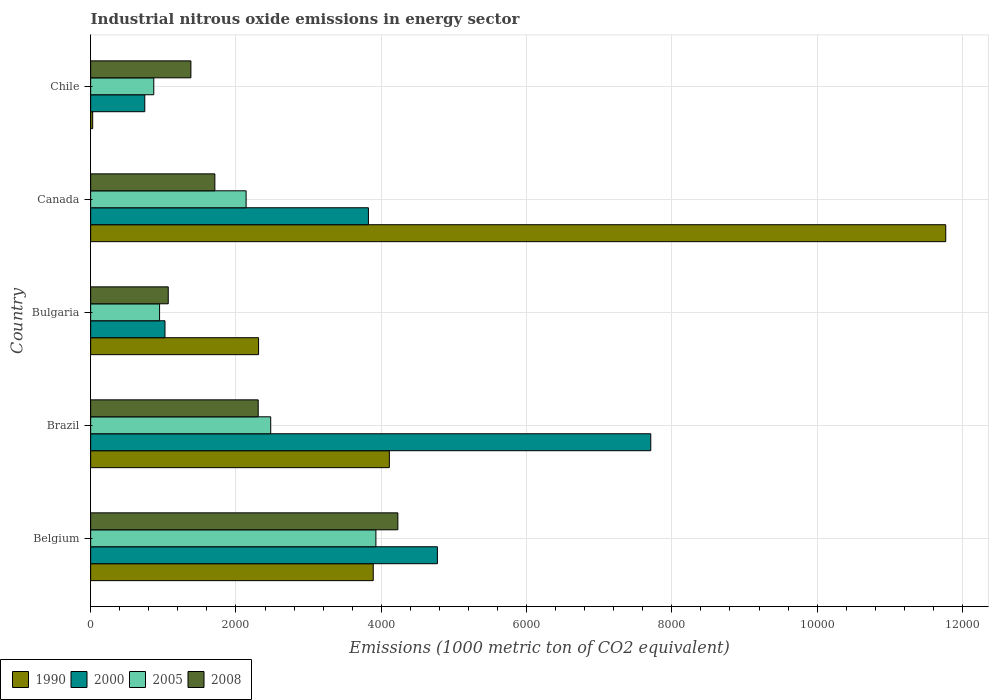How many bars are there on the 1st tick from the bottom?
Provide a succinct answer. 4. What is the amount of industrial nitrous oxide emitted in 2000 in Belgium?
Provide a short and direct response. 4772.6. Across all countries, what is the maximum amount of industrial nitrous oxide emitted in 2005?
Ensure brevity in your answer.  3926.3. Across all countries, what is the minimum amount of industrial nitrous oxide emitted in 2005?
Keep it short and to the point. 868.8. In which country was the amount of industrial nitrous oxide emitted in 2008 maximum?
Your answer should be very brief. Belgium. What is the total amount of industrial nitrous oxide emitted in 2000 in the graph?
Provide a succinct answer. 1.81e+04. What is the difference between the amount of industrial nitrous oxide emitted in 1990 in Belgium and that in Chile?
Make the answer very short. 3861.7. What is the difference between the amount of industrial nitrous oxide emitted in 2000 in Chile and the amount of industrial nitrous oxide emitted in 1990 in Bulgaria?
Give a very brief answer. -1566.3. What is the average amount of industrial nitrous oxide emitted in 2008 per country?
Offer a very short reply. 2138.42. What is the difference between the amount of industrial nitrous oxide emitted in 2008 and amount of industrial nitrous oxide emitted in 2000 in Canada?
Your answer should be very brief. -2113.7. What is the ratio of the amount of industrial nitrous oxide emitted in 1990 in Bulgaria to that in Canada?
Provide a short and direct response. 0.2. Is the difference between the amount of industrial nitrous oxide emitted in 2008 in Brazil and Canada greater than the difference between the amount of industrial nitrous oxide emitted in 2000 in Brazil and Canada?
Make the answer very short. No. What is the difference between the highest and the second highest amount of industrial nitrous oxide emitted in 1990?
Your response must be concise. 7658.6. What is the difference between the highest and the lowest amount of industrial nitrous oxide emitted in 2005?
Offer a terse response. 3057.5. Is it the case that in every country, the sum of the amount of industrial nitrous oxide emitted in 2005 and amount of industrial nitrous oxide emitted in 1990 is greater than the sum of amount of industrial nitrous oxide emitted in 2000 and amount of industrial nitrous oxide emitted in 2008?
Your answer should be compact. No. What does the 4th bar from the bottom in Bulgaria represents?
Keep it short and to the point. 2008. Is it the case that in every country, the sum of the amount of industrial nitrous oxide emitted in 1990 and amount of industrial nitrous oxide emitted in 2005 is greater than the amount of industrial nitrous oxide emitted in 2008?
Make the answer very short. No. What is the difference between two consecutive major ticks on the X-axis?
Make the answer very short. 2000. Are the values on the major ticks of X-axis written in scientific E-notation?
Keep it short and to the point. No. Where does the legend appear in the graph?
Make the answer very short. Bottom left. How many legend labels are there?
Provide a short and direct response. 4. How are the legend labels stacked?
Ensure brevity in your answer.  Horizontal. What is the title of the graph?
Ensure brevity in your answer.  Industrial nitrous oxide emissions in energy sector. What is the label or title of the X-axis?
Give a very brief answer. Emissions (1000 metric ton of CO2 equivalent). What is the Emissions (1000 metric ton of CO2 equivalent) in 1990 in Belgium?
Your answer should be very brief. 3889.6. What is the Emissions (1000 metric ton of CO2 equivalent) in 2000 in Belgium?
Make the answer very short. 4772.6. What is the Emissions (1000 metric ton of CO2 equivalent) of 2005 in Belgium?
Offer a terse response. 3926.3. What is the Emissions (1000 metric ton of CO2 equivalent) of 2008 in Belgium?
Your answer should be compact. 4228.6. What is the Emissions (1000 metric ton of CO2 equivalent) in 1990 in Brazil?
Ensure brevity in your answer.  4111.4. What is the Emissions (1000 metric ton of CO2 equivalent) in 2000 in Brazil?
Your response must be concise. 7709.7. What is the Emissions (1000 metric ton of CO2 equivalent) in 2005 in Brazil?
Provide a short and direct response. 2478.5. What is the Emissions (1000 metric ton of CO2 equivalent) of 2008 in Brazil?
Give a very brief answer. 2306.2. What is the Emissions (1000 metric ton of CO2 equivalent) of 1990 in Bulgaria?
Give a very brief answer. 2311.2. What is the Emissions (1000 metric ton of CO2 equivalent) of 2000 in Bulgaria?
Keep it short and to the point. 1023. What is the Emissions (1000 metric ton of CO2 equivalent) in 2005 in Bulgaria?
Offer a terse response. 948.6. What is the Emissions (1000 metric ton of CO2 equivalent) of 2008 in Bulgaria?
Offer a very short reply. 1068. What is the Emissions (1000 metric ton of CO2 equivalent) of 1990 in Canada?
Offer a very short reply. 1.18e+04. What is the Emissions (1000 metric ton of CO2 equivalent) of 2000 in Canada?
Your answer should be very brief. 3823.3. What is the Emissions (1000 metric ton of CO2 equivalent) in 2005 in Canada?
Your response must be concise. 2139.7. What is the Emissions (1000 metric ton of CO2 equivalent) in 2008 in Canada?
Provide a short and direct response. 1709.6. What is the Emissions (1000 metric ton of CO2 equivalent) of 1990 in Chile?
Give a very brief answer. 27.9. What is the Emissions (1000 metric ton of CO2 equivalent) in 2000 in Chile?
Your answer should be compact. 744.9. What is the Emissions (1000 metric ton of CO2 equivalent) of 2005 in Chile?
Keep it short and to the point. 868.8. What is the Emissions (1000 metric ton of CO2 equivalent) in 2008 in Chile?
Provide a succinct answer. 1379.7. Across all countries, what is the maximum Emissions (1000 metric ton of CO2 equivalent) in 1990?
Provide a succinct answer. 1.18e+04. Across all countries, what is the maximum Emissions (1000 metric ton of CO2 equivalent) in 2000?
Ensure brevity in your answer.  7709.7. Across all countries, what is the maximum Emissions (1000 metric ton of CO2 equivalent) of 2005?
Ensure brevity in your answer.  3926.3. Across all countries, what is the maximum Emissions (1000 metric ton of CO2 equivalent) in 2008?
Offer a very short reply. 4228.6. Across all countries, what is the minimum Emissions (1000 metric ton of CO2 equivalent) in 1990?
Offer a very short reply. 27.9. Across all countries, what is the minimum Emissions (1000 metric ton of CO2 equivalent) in 2000?
Offer a very short reply. 744.9. Across all countries, what is the minimum Emissions (1000 metric ton of CO2 equivalent) of 2005?
Offer a terse response. 868.8. Across all countries, what is the minimum Emissions (1000 metric ton of CO2 equivalent) of 2008?
Your response must be concise. 1068. What is the total Emissions (1000 metric ton of CO2 equivalent) in 1990 in the graph?
Ensure brevity in your answer.  2.21e+04. What is the total Emissions (1000 metric ton of CO2 equivalent) of 2000 in the graph?
Make the answer very short. 1.81e+04. What is the total Emissions (1000 metric ton of CO2 equivalent) in 2005 in the graph?
Ensure brevity in your answer.  1.04e+04. What is the total Emissions (1000 metric ton of CO2 equivalent) of 2008 in the graph?
Offer a very short reply. 1.07e+04. What is the difference between the Emissions (1000 metric ton of CO2 equivalent) in 1990 in Belgium and that in Brazil?
Keep it short and to the point. -221.8. What is the difference between the Emissions (1000 metric ton of CO2 equivalent) in 2000 in Belgium and that in Brazil?
Give a very brief answer. -2937.1. What is the difference between the Emissions (1000 metric ton of CO2 equivalent) in 2005 in Belgium and that in Brazil?
Provide a short and direct response. 1447.8. What is the difference between the Emissions (1000 metric ton of CO2 equivalent) of 2008 in Belgium and that in Brazil?
Your answer should be compact. 1922.4. What is the difference between the Emissions (1000 metric ton of CO2 equivalent) in 1990 in Belgium and that in Bulgaria?
Your answer should be compact. 1578.4. What is the difference between the Emissions (1000 metric ton of CO2 equivalent) of 2000 in Belgium and that in Bulgaria?
Your answer should be very brief. 3749.6. What is the difference between the Emissions (1000 metric ton of CO2 equivalent) in 2005 in Belgium and that in Bulgaria?
Give a very brief answer. 2977.7. What is the difference between the Emissions (1000 metric ton of CO2 equivalent) in 2008 in Belgium and that in Bulgaria?
Your answer should be very brief. 3160.6. What is the difference between the Emissions (1000 metric ton of CO2 equivalent) of 1990 in Belgium and that in Canada?
Provide a succinct answer. -7880.4. What is the difference between the Emissions (1000 metric ton of CO2 equivalent) in 2000 in Belgium and that in Canada?
Your response must be concise. 949.3. What is the difference between the Emissions (1000 metric ton of CO2 equivalent) in 2005 in Belgium and that in Canada?
Ensure brevity in your answer.  1786.6. What is the difference between the Emissions (1000 metric ton of CO2 equivalent) in 2008 in Belgium and that in Canada?
Provide a short and direct response. 2519. What is the difference between the Emissions (1000 metric ton of CO2 equivalent) in 1990 in Belgium and that in Chile?
Give a very brief answer. 3861.7. What is the difference between the Emissions (1000 metric ton of CO2 equivalent) of 2000 in Belgium and that in Chile?
Your response must be concise. 4027.7. What is the difference between the Emissions (1000 metric ton of CO2 equivalent) in 2005 in Belgium and that in Chile?
Make the answer very short. 3057.5. What is the difference between the Emissions (1000 metric ton of CO2 equivalent) in 2008 in Belgium and that in Chile?
Ensure brevity in your answer.  2848.9. What is the difference between the Emissions (1000 metric ton of CO2 equivalent) of 1990 in Brazil and that in Bulgaria?
Provide a succinct answer. 1800.2. What is the difference between the Emissions (1000 metric ton of CO2 equivalent) of 2000 in Brazil and that in Bulgaria?
Offer a terse response. 6686.7. What is the difference between the Emissions (1000 metric ton of CO2 equivalent) in 2005 in Brazil and that in Bulgaria?
Provide a succinct answer. 1529.9. What is the difference between the Emissions (1000 metric ton of CO2 equivalent) in 2008 in Brazil and that in Bulgaria?
Provide a succinct answer. 1238.2. What is the difference between the Emissions (1000 metric ton of CO2 equivalent) in 1990 in Brazil and that in Canada?
Your response must be concise. -7658.6. What is the difference between the Emissions (1000 metric ton of CO2 equivalent) in 2000 in Brazil and that in Canada?
Provide a short and direct response. 3886.4. What is the difference between the Emissions (1000 metric ton of CO2 equivalent) in 2005 in Brazil and that in Canada?
Keep it short and to the point. 338.8. What is the difference between the Emissions (1000 metric ton of CO2 equivalent) of 2008 in Brazil and that in Canada?
Your answer should be compact. 596.6. What is the difference between the Emissions (1000 metric ton of CO2 equivalent) in 1990 in Brazil and that in Chile?
Your answer should be compact. 4083.5. What is the difference between the Emissions (1000 metric ton of CO2 equivalent) of 2000 in Brazil and that in Chile?
Provide a succinct answer. 6964.8. What is the difference between the Emissions (1000 metric ton of CO2 equivalent) in 2005 in Brazil and that in Chile?
Offer a terse response. 1609.7. What is the difference between the Emissions (1000 metric ton of CO2 equivalent) in 2008 in Brazil and that in Chile?
Provide a succinct answer. 926.5. What is the difference between the Emissions (1000 metric ton of CO2 equivalent) in 1990 in Bulgaria and that in Canada?
Make the answer very short. -9458.8. What is the difference between the Emissions (1000 metric ton of CO2 equivalent) of 2000 in Bulgaria and that in Canada?
Provide a succinct answer. -2800.3. What is the difference between the Emissions (1000 metric ton of CO2 equivalent) in 2005 in Bulgaria and that in Canada?
Make the answer very short. -1191.1. What is the difference between the Emissions (1000 metric ton of CO2 equivalent) in 2008 in Bulgaria and that in Canada?
Keep it short and to the point. -641.6. What is the difference between the Emissions (1000 metric ton of CO2 equivalent) of 1990 in Bulgaria and that in Chile?
Your response must be concise. 2283.3. What is the difference between the Emissions (1000 metric ton of CO2 equivalent) in 2000 in Bulgaria and that in Chile?
Your response must be concise. 278.1. What is the difference between the Emissions (1000 metric ton of CO2 equivalent) of 2005 in Bulgaria and that in Chile?
Your answer should be compact. 79.8. What is the difference between the Emissions (1000 metric ton of CO2 equivalent) in 2008 in Bulgaria and that in Chile?
Give a very brief answer. -311.7. What is the difference between the Emissions (1000 metric ton of CO2 equivalent) in 1990 in Canada and that in Chile?
Offer a terse response. 1.17e+04. What is the difference between the Emissions (1000 metric ton of CO2 equivalent) in 2000 in Canada and that in Chile?
Give a very brief answer. 3078.4. What is the difference between the Emissions (1000 metric ton of CO2 equivalent) of 2005 in Canada and that in Chile?
Provide a short and direct response. 1270.9. What is the difference between the Emissions (1000 metric ton of CO2 equivalent) in 2008 in Canada and that in Chile?
Offer a terse response. 329.9. What is the difference between the Emissions (1000 metric ton of CO2 equivalent) in 1990 in Belgium and the Emissions (1000 metric ton of CO2 equivalent) in 2000 in Brazil?
Your answer should be very brief. -3820.1. What is the difference between the Emissions (1000 metric ton of CO2 equivalent) in 1990 in Belgium and the Emissions (1000 metric ton of CO2 equivalent) in 2005 in Brazil?
Your answer should be very brief. 1411.1. What is the difference between the Emissions (1000 metric ton of CO2 equivalent) of 1990 in Belgium and the Emissions (1000 metric ton of CO2 equivalent) of 2008 in Brazil?
Your answer should be very brief. 1583.4. What is the difference between the Emissions (1000 metric ton of CO2 equivalent) of 2000 in Belgium and the Emissions (1000 metric ton of CO2 equivalent) of 2005 in Brazil?
Give a very brief answer. 2294.1. What is the difference between the Emissions (1000 metric ton of CO2 equivalent) of 2000 in Belgium and the Emissions (1000 metric ton of CO2 equivalent) of 2008 in Brazil?
Offer a terse response. 2466.4. What is the difference between the Emissions (1000 metric ton of CO2 equivalent) of 2005 in Belgium and the Emissions (1000 metric ton of CO2 equivalent) of 2008 in Brazil?
Keep it short and to the point. 1620.1. What is the difference between the Emissions (1000 metric ton of CO2 equivalent) in 1990 in Belgium and the Emissions (1000 metric ton of CO2 equivalent) in 2000 in Bulgaria?
Your answer should be compact. 2866.6. What is the difference between the Emissions (1000 metric ton of CO2 equivalent) of 1990 in Belgium and the Emissions (1000 metric ton of CO2 equivalent) of 2005 in Bulgaria?
Ensure brevity in your answer.  2941. What is the difference between the Emissions (1000 metric ton of CO2 equivalent) of 1990 in Belgium and the Emissions (1000 metric ton of CO2 equivalent) of 2008 in Bulgaria?
Ensure brevity in your answer.  2821.6. What is the difference between the Emissions (1000 metric ton of CO2 equivalent) in 2000 in Belgium and the Emissions (1000 metric ton of CO2 equivalent) in 2005 in Bulgaria?
Your response must be concise. 3824. What is the difference between the Emissions (1000 metric ton of CO2 equivalent) of 2000 in Belgium and the Emissions (1000 metric ton of CO2 equivalent) of 2008 in Bulgaria?
Keep it short and to the point. 3704.6. What is the difference between the Emissions (1000 metric ton of CO2 equivalent) of 2005 in Belgium and the Emissions (1000 metric ton of CO2 equivalent) of 2008 in Bulgaria?
Your response must be concise. 2858.3. What is the difference between the Emissions (1000 metric ton of CO2 equivalent) in 1990 in Belgium and the Emissions (1000 metric ton of CO2 equivalent) in 2000 in Canada?
Offer a very short reply. 66.3. What is the difference between the Emissions (1000 metric ton of CO2 equivalent) in 1990 in Belgium and the Emissions (1000 metric ton of CO2 equivalent) in 2005 in Canada?
Provide a succinct answer. 1749.9. What is the difference between the Emissions (1000 metric ton of CO2 equivalent) of 1990 in Belgium and the Emissions (1000 metric ton of CO2 equivalent) of 2008 in Canada?
Offer a terse response. 2180. What is the difference between the Emissions (1000 metric ton of CO2 equivalent) of 2000 in Belgium and the Emissions (1000 metric ton of CO2 equivalent) of 2005 in Canada?
Provide a succinct answer. 2632.9. What is the difference between the Emissions (1000 metric ton of CO2 equivalent) of 2000 in Belgium and the Emissions (1000 metric ton of CO2 equivalent) of 2008 in Canada?
Your answer should be compact. 3063. What is the difference between the Emissions (1000 metric ton of CO2 equivalent) of 2005 in Belgium and the Emissions (1000 metric ton of CO2 equivalent) of 2008 in Canada?
Offer a very short reply. 2216.7. What is the difference between the Emissions (1000 metric ton of CO2 equivalent) of 1990 in Belgium and the Emissions (1000 metric ton of CO2 equivalent) of 2000 in Chile?
Provide a succinct answer. 3144.7. What is the difference between the Emissions (1000 metric ton of CO2 equivalent) of 1990 in Belgium and the Emissions (1000 metric ton of CO2 equivalent) of 2005 in Chile?
Keep it short and to the point. 3020.8. What is the difference between the Emissions (1000 metric ton of CO2 equivalent) in 1990 in Belgium and the Emissions (1000 metric ton of CO2 equivalent) in 2008 in Chile?
Provide a succinct answer. 2509.9. What is the difference between the Emissions (1000 metric ton of CO2 equivalent) in 2000 in Belgium and the Emissions (1000 metric ton of CO2 equivalent) in 2005 in Chile?
Keep it short and to the point. 3903.8. What is the difference between the Emissions (1000 metric ton of CO2 equivalent) in 2000 in Belgium and the Emissions (1000 metric ton of CO2 equivalent) in 2008 in Chile?
Make the answer very short. 3392.9. What is the difference between the Emissions (1000 metric ton of CO2 equivalent) of 2005 in Belgium and the Emissions (1000 metric ton of CO2 equivalent) of 2008 in Chile?
Your response must be concise. 2546.6. What is the difference between the Emissions (1000 metric ton of CO2 equivalent) in 1990 in Brazil and the Emissions (1000 metric ton of CO2 equivalent) in 2000 in Bulgaria?
Keep it short and to the point. 3088.4. What is the difference between the Emissions (1000 metric ton of CO2 equivalent) in 1990 in Brazil and the Emissions (1000 metric ton of CO2 equivalent) in 2005 in Bulgaria?
Your answer should be very brief. 3162.8. What is the difference between the Emissions (1000 metric ton of CO2 equivalent) of 1990 in Brazil and the Emissions (1000 metric ton of CO2 equivalent) of 2008 in Bulgaria?
Offer a very short reply. 3043.4. What is the difference between the Emissions (1000 metric ton of CO2 equivalent) in 2000 in Brazil and the Emissions (1000 metric ton of CO2 equivalent) in 2005 in Bulgaria?
Your answer should be compact. 6761.1. What is the difference between the Emissions (1000 metric ton of CO2 equivalent) in 2000 in Brazil and the Emissions (1000 metric ton of CO2 equivalent) in 2008 in Bulgaria?
Your answer should be compact. 6641.7. What is the difference between the Emissions (1000 metric ton of CO2 equivalent) in 2005 in Brazil and the Emissions (1000 metric ton of CO2 equivalent) in 2008 in Bulgaria?
Ensure brevity in your answer.  1410.5. What is the difference between the Emissions (1000 metric ton of CO2 equivalent) of 1990 in Brazil and the Emissions (1000 metric ton of CO2 equivalent) of 2000 in Canada?
Provide a short and direct response. 288.1. What is the difference between the Emissions (1000 metric ton of CO2 equivalent) in 1990 in Brazil and the Emissions (1000 metric ton of CO2 equivalent) in 2005 in Canada?
Give a very brief answer. 1971.7. What is the difference between the Emissions (1000 metric ton of CO2 equivalent) in 1990 in Brazil and the Emissions (1000 metric ton of CO2 equivalent) in 2008 in Canada?
Your response must be concise. 2401.8. What is the difference between the Emissions (1000 metric ton of CO2 equivalent) in 2000 in Brazil and the Emissions (1000 metric ton of CO2 equivalent) in 2005 in Canada?
Offer a very short reply. 5570. What is the difference between the Emissions (1000 metric ton of CO2 equivalent) of 2000 in Brazil and the Emissions (1000 metric ton of CO2 equivalent) of 2008 in Canada?
Offer a very short reply. 6000.1. What is the difference between the Emissions (1000 metric ton of CO2 equivalent) in 2005 in Brazil and the Emissions (1000 metric ton of CO2 equivalent) in 2008 in Canada?
Make the answer very short. 768.9. What is the difference between the Emissions (1000 metric ton of CO2 equivalent) of 1990 in Brazil and the Emissions (1000 metric ton of CO2 equivalent) of 2000 in Chile?
Your answer should be compact. 3366.5. What is the difference between the Emissions (1000 metric ton of CO2 equivalent) of 1990 in Brazil and the Emissions (1000 metric ton of CO2 equivalent) of 2005 in Chile?
Your answer should be very brief. 3242.6. What is the difference between the Emissions (1000 metric ton of CO2 equivalent) in 1990 in Brazil and the Emissions (1000 metric ton of CO2 equivalent) in 2008 in Chile?
Your answer should be compact. 2731.7. What is the difference between the Emissions (1000 metric ton of CO2 equivalent) in 2000 in Brazil and the Emissions (1000 metric ton of CO2 equivalent) in 2005 in Chile?
Your response must be concise. 6840.9. What is the difference between the Emissions (1000 metric ton of CO2 equivalent) of 2000 in Brazil and the Emissions (1000 metric ton of CO2 equivalent) of 2008 in Chile?
Offer a terse response. 6330. What is the difference between the Emissions (1000 metric ton of CO2 equivalent) in 2005 in Brazil and the Emissions (1000 metric ton of CO2 equivalent) in 2008 in Chile?
Offer a terse response. 1098.8. What is the difference between the Emissions (1000 metric ton of CO2 equivalent) of 1990 in Bulgaria and the Emissions (1000 metric ton of CO2 equivalent) of 2000 in Canada?
Make the answer very short. -1512.1. What is the difference between the Emissions (1000 metric ton of CO2 equivalent) of 1990 in Bulgaria and the Emissions (1000 metric ton of CO2 equivalent) of 2005 in Canada?
Your answer should be very brief. 171.5. What is the difference between the Emissions (1000 metric ton of CO2 equivalent) in 1990 in Bulgaria and the Emissions (1000 metric ton of CO2 equivalent) in 2008 in Canada?
Ensure brevity in your answer.  601.6. What is the difference between the Emissions (1000 metric ton of CO2 equivalent) of 2000 in Bulgaria and the Emissions (1000 metric ton of CO2 equivalent) of 2005 in Canada?
Make the answer very short. -1116.7. What is the difference between the Emissions (1000 metric ton of CO2 equivalent) of 2000 in Bulgaria and the Emissions (1000 metric ton of CO2 equivalent) of 2008 in Canada?
Make the answer very short. -686.6. What is the difference between the Emissions (1000 metric ton of CO2 equivalent) in 2005 in Bulgaria and the Emissions (1000 metric ton of CO2 equivalent) in 2008 in Canada?
Keep it short and to the point. -761. What is the difference between the Emissions (1000 metric ton of CO2 equivalent) in 1990 in Bulgaria and the Emissions (1000 metric ton of CO2 equivalent) in 2000 in Chile?
Offer a terse response. 1566.3. What is the difference between the Emissions (1000 metric ton of CO2 equivalent) in 1990 in Bulgaria and the Emissions (1000 metric ton of CO2 equivalent) in 2005 in Chile?
Make the answer very short. 1442.4. What is the difference between the Emissions (1000 metric ton of CO2 equivalent) in 1990 in Bulgaria and the Emissions (1000 metric ton of CO2 equivalent) in 2008 in Chile?
Offer a terse response. 931.5. What is the difference between the Emissions (1000 metric ton of CO2 equivalent) in 2000 in Bulgaria and the Emissions (1000 metric ton of CO2 equivalent) in 2005 in Chile?
Provide a short and direct response. 154.2. What is the difference between the Emissions (1000 metric ton of CO2 equivalent) in 2000 in Bulgaria and the Emissions (1000 metric ton of CO2 equivalent) in 2008 in Chile?
Give a very brief answer. -356.7. What is the difference between the Emissions (1000 metric ton of CO2 equivalent) of 2005 in Bulgaria and the Emissions (1000 metric ton of CO2 equivalent) of 2008 in Chile?
Provide a succinct answer. -431.1. What is the difference between the Emissions (1000 metric ton of CO2 equivalent) in 1990 in Canada and the Emissions (1000 metric ton of CO2 equivalent) in 2000 in Chile?
Your answer should be compact. 1.10e+04. What is the difference between the Emissions (1000 metric ton of CO2 equivalent) in 1990 in Canada and the Emissions (1000 metric ton of CO2 equivalent) in 2005 in Chile?
Ensure brevity in your answer.  1.09e+04. What is the difference between the Emissions (1000 metric ton of CO2 equivalent) of 1990 in Canada and the Emissions (1000 metric ton of CO2 equivalent) of 2008 in Chile?
Provide a short and direct response. 1.04e+04. What is the difference between the Emissions (1000 metric ton of CO2 equivalent) in 2000 in Canada and the Emissions (1000 metric ton of CO2 equivalent) in 2005 in Chile?
Offer a very short reply. 2954.5. What is the difference between the Emissions (1000 metric ton of CO2 equivalent) in 2000 in Canada and the Emissions (1000 metric ton of CO2 equivalent) in 2008 in Chile?
Ensure brevity in your answer.  2443.6. What is the difference between the Emissions (1000 metric ton of CO2 equivalent) of 2005 in Canada and the Emissions (1000 metric ton of CO2 equivalent) of 2008 in Chile?
Offer a terse response. 760. What is the average Emissions (1000 metric ton of CO2 equivalent) of 1990 per country?
Ensure brevity in your answer.  4422.02. What is the average Emissions (1000 metric ton of CO2 equivalent) in 2000 per country?
Provide a succinct answer. 3614.7. What is the average Emissions (1000 metric ton of CO2 equivalent) in 2005 per country?
Make the answer very short. 2072.38. What is the average Emissions (1000 metric ton of CO2 equivalent) in 2008 per country?
Offer a terse response. 2138.42. What is the difference between the Emissions (1000 metric ton of CO2 equivalent) of 1990 and Emissions (1000 metric ton of CO2 equivalent) of 2000 in Belgium?
Your answer should be very brief. -883. What is the difference between the Emissions (1000 metric ton of CO2 equivalent) in 1990 and Emissions (1000 metric ton of CO2 equivalent) in 2005 in Belgium?
Offer a very short reply. -36.7. What is the difference between the Emissions (1000 metric ton of CO2 equivalent) of 1990 and Emissions (1000 metric ton of CO2 equivalent) of 2008 in Belgium?
Your answer should be very brief. -339. What is the difference between the Emissions (1000 metric ton of CO2 equivalent) in 2000 and Emissions (1000 metric ton of CO2 equivalent) in 2005 in Belgium?
Offer a terse response. 846.3. What is the difference between the Emissions (1000 metric ton of CO2 equivalent) of 2000 and Emissions (1000 metric ton of CO2 equivalent) of 2008 in Belgium?
Your response must be concise. 544. What is the difference between the Emissions (1000 metric ton of CO2 equivalent) in 2005 and Emissions (1000 metric ton of CO2 equivalent) in 2008 in Belgium?
Keep it short and to the point. -302.3. What is the difference between the Emissions (1000 metric ton of CO2 equivalent) in 1990 and Emissions (1000 metric ton of CO2 equivalent) in 2000 in Brazil?
Ensure brevity in your answer.  -3598.3. What is the difference between the Emissions (1000 metric ton of CO2 equivalent) in 1990 and Emissions (1000 metric ton of CO2 equivalent) in 2005 in Brazil?
Your response must be concise. 1632.9. What is the difference between the Emissions (1000 metric ton of CO2 equivalent) in 1990 and Emissions (1000 metric ton of CO2 equivalent) in 2008 in Brazil?
Make the answer very short. 1805.2. What is the difference between the Emissions (1000 metric ton of CO2 equivalent) of 2000 and Emissions (1000 metric ton of CO2 equivalent) of 2005 in Brazil?
Offer a very short reply. 5231.2. What is the difference between the Emissions (1000 metric ton of CO2 equivalent) in 2000 and Emissions (1000 metric ton of CO2 equivalent) in 2008 in Brazil?
Your answer should be compact. 5403.5. What is the difference between the Emissions (1000 metric ton of CO2 equivalent) in 2005 and Emissions (1000 metric ton of CO2 equivalent) in 2008 in Brazil?
Give a very brief answer. 172.3. What is the difference between the Emissions (1000 metric ton of CO2 equivalent) in 1990 and Emissions (1000 metric ton of CO2 equivalent) in 2000 in Bulgaria?
Give a very brief answer. 1288.2. What is the difference between the Emissions (1000 metric ton of CO2 equivalent) of 1990 and Emissions (1000 metric ton of CO2 equivalent) of 2005 in Bulgaria?
Your answer should be very brief. 1362.6. What is the difference between the Emissions (1000 metric ton of CO2 equivalent) of 1990 and Emissions (1000 metric ton of CO2 equivalent) of 2008 in Bulgaria?
Your answer should be compact. 1243.2. What is the difference between the Emissions (1000 metric ton of CO2 equivalent) of 2000 and Emissions (1000 metric ton of CO2 equivalent) of 2005 in Bulgaria?
Provide a succinct answer. 74.4. What is the difference between the Emissions (1000 metric ton of CO2 equivalent) of 2000 and Emissions (1000 metric ton of CO2 equivalent) of 2008 in Bulgaria?
Offer a terse response. -45. What is the difference between the Emissions (1000 metric ton of CO2 equivalent) of 2005 and Emissions (1000 metric ton of CO2 equivalent) of 2008 in Bulgaria?
Give a very brief answer. -119.4. What is the difference between the Emissions (1000 metric ton of CO2 equivalent) of 1990 and Emissions (1000 metric ton of CO2 equivalent) of 2000 in Canada?
Your response must be concise. 7946.7. What is the difference between the Emissions (1000 metric ton of CO2 equivalent) in 1990 and Emissions (1000 metric ton of CO2 equivalent) in 2005 in Canada?
Provide a succinct answer. 9630.3. What is the difference between the Emissions (1000 metric ton of CO2 equivalent) in 1990 and Emissions (1000 metric ton of CO2 equivalent) in 2008 in Canada?
Offer a terse response. 1.01e+04. What is the difference between the Emissions (1000 metric ton of CO2 equivalent) of 2000 and Emissions (1000 metric ton of CO2 equivalent) of 2005 in Canada?
Give a very brief answer. 1683.6. What is the difference between the Emissions (1000 metric ton of CO2 equivalent) of 2000 and Emissions (1000 metric ton of CO2 equivalent) of 2008 in Canada?
Offer a terse response. 2113.7. What is the difference between the Emissions (1000 metric ton of CO2 equivalent) in 2005 and Emissions (1000 metric ton of CO2 equivalent) in 2008 in Canada?
Offer a terse response. 430.1. What is the difference between the Emissions (1000 metric ton of CO2 equivalent) in 1990 and Emissions (1000 metric ton of CO2 equivalent) in 2000 in Chile?
Your answer should be very brief. -717. What is the difference between the Emissions (1000 metric ton of CO2 equivalent) of 1990 and Emissions (1000 metric ton of CO2 equivalent) of 2005 in Chile?
Make the answer very short. -840.9. What is the difference between the Emissions (1000 metric ton of CO2 equivalent) in 1990 and Emissions (1000 metric ton of CO2 equivalent) in 2008 in Chile?
Offer a terse response. -1351.8. What is the difference between the Emissions (1000 metric ton of CO2 equivalent) of 2000 and Emissions (1000 metric ton of CO2 equivalent) of 2005 in Chile?
Ensure brevity in your answer.  -123.9. What is the difference between the Emissions (1000 metric ton of CO2 equivalent) in 2000 and Emissions (1000 metric ton of CO2 equivalent) in 2008 in Chile?
Offer a very short reply. -634.8. What is the difference between the Emissions (1000 metric ton of CO2 equivalent) of 2005 and Emissions (1000 metric ton of CO2 equivalent) of 2008 in Chile?
Provide a succinct answer. -510.9. What is the ratio of the Emissions (1000 metric ton of CO2 equivalent) in 1990 in Belgium to that in Brazil?
Give a very brief answer. 0.95. What is the ratio of the Emissions (1000 metric ton of CO2 equivalent) in 2000 in Belgium to that in Brazil?
Your response must be concise. 0.62. What is the ratio of the Emissions (1000 metric ton of CO2 equivalent) of 2005 in Belgium to that in Brazil?
Your answer should be compact. 1.58. What is the ratio of the Emissions (1000 metric ton of CO2 equivalent) in 2008 in Belgium to that in Brazil?
Your answer should be very brief. 1.83. What is the ratio of the Emissions (1000 metric ton of CO2 equivalent) of 1990 in Belgium to that in Bulgaria?
Offer a terse response. 1.68. What is the ratio of the Emissions (1000 metric ton of CO2 equivalent) in 2000 in Belgium to that in Bulgaria?
Your answer should be compact. 4.67. What is the ratio of the Emissions (1000 metric ton of CO2 equivalent) in 2005 in Belgium to that in Bulgaria?
Provide a short and direct response. 4.14. What is the ratio of the Emissions (1000 metric ton of CO2 equivalent) of 2008 in Belgium to that in Bulgaria?
Your answer should be compact. 3.96. What is the ratio of the Emissions (1000 metric ton of CO2 equivalent) in 1990 in Belgium to that in Canada?
Keep it short and to the point. 0.33. What is the ratio of the Emissions (1000 metric ton of CO2 equivalent) in 2000 in Belgium to that in Canada?
Keep it short and to the point. 1.25. What is the ratio of the Emissions (1000 metric ton of CO2 equivalent) of 2005 in Belgium to that in Canada?
Ensure brevity in your answer.  1.83. What is the ratio of the Emissions (1000 metric ton of CO2 equivalent) of 2008 in Belgium to that in Canada?
Give a very brief answer. 2.47. What is the ratio of the Emissions (1000 metric ton of CO2 equivalent) of 1990 in Belgium to that in Chile?
Ensure brevity in your answer.  139.41. What is the ratio of the Emissions (1000 metric ton of CO2 equivalent) in 2000 in Belgium to that in Chile?
Offer a terse response. 6.41. What is the ratio of the Emissions (1000 metric ton of CO2 equivalent) in 2005 in Belgium to that in Chile?
Ensure brevity in your answer.  4.52. What is the ratio of the Emissions (1000 metric ton of CO2 equivalent) in 2008 in Belgium to that in Chile?
Provide a short and direct response. 3.06. What is the ratio of the Emissions (1000 metric ton of CO2 equivalent) in 1990 in Brazil to that in Bulgaria?
Make the answer very short. 1.78. What is the ratio of the Emissions (1000 metric ton of CO2 equivalent) of 2000 in Brazil to that in Bulgaria?
Your answer should be compact. 7.54. What is the ratio of the Emissions (1000 metric ton of CO2 equivalent) in 2005 in Brazil to that in Bulgaria?
Offer a very short reply. 2.61. What is the ratio of the Emissions (1000 metric ton of CO2 equivalent) in 2008 in Brazil to that in Bulgaria?
Make the answer very short. 2.16. What is the ratio of the Emissions (1000 metric ton of CO2 equivalent) of 1990 in Brazil to that in Canada?
Keep it short and to the point. 0.35. What is the ratio of the Emissions (1000 metric ton of CO2 equivalent) in 2000 in Brazil to that in Canada?
Provide a short and direct response. 2.02. What is the ratio of the Emissions (1000 metric ton of CO2 equivalent) in 2005 in Brazil to that in Canada?
Provide a short and direct response. 1.16. What is the ratio of the Emissions (1000 metric ton of CO2 equivalent) of 2008 in Brazil to that in Canada?
Offer a terse response. 1.35. What is the ratio of the Emissions (1000 metric ton of CO2 equivalent) of 1990 in Brazil to that in Chile?
Provide a short and direct response. 147.36. What is the ratio of the Emissions (1000 metric ton of CO2 equivalent) of 2000 in Brazil to that in Chile?
Provide a short and direct response. 10.35. What is the ratio of the Emissions (1000 metric ton of CO2 equivalent) in 2005 in Brazil to that in Chile?
Your response must be concise. 2.85. What is the ratio of the Emissions (1000 metric ton of CO2 equivalent) of 2008 in Brazil to that in Chile?
Your answer should be compact. 1.67. What is the ratio of the Emissions (1000 metric ton of CO2 equivalent) in 1990 in Bulgaria to that in Canada?
Your response must be concise. 0.2. What is the ratio of the Emissions (1000 metric ton of CO2 equivalent) of 2000 in Bulgaria to that in Canada?
Your answer should be very brief. 0.27. What is the ratio of the Emissions (1000 metric ton of CO2 equivalent) in 2005 in Bulgaria to that in Canada?
Your response must be concise. 0.44. What is the ratio of the Emissions (1000 metric ton of CO2 equivalent) of 2008 in Bulgaria to that in Canada?
Offer a very short reply. 0.62. What is the ratio of the Emissions (1000 metric ton of CO2 equivalent) in 1990 in Bulgaria to that in Chile?
Your response must be concise. 82.84. What is the ratio of the Emissions (1000 metric ton of CO2 equivalent) of 2000 in Bulgaria to that in Chile?
Keep it short and to the point. 1.37. What is the ratio of the Emissions (1000 metric ton of CO2 equivalent) of 2005 in Bulgaria to that in Chile?
Your response must be concise. 1.09. What is the ratio of the Emissions (1000 metric ton of CO2 equivalent) of 2008 in Bulgaria to that in Chile?
Keep it short and to the point. 0.77. What is the ratio of the Emissions (1000 metric ton of CO2 equivalent) in 1990 in Canada to that in Chile?
Provide a succinct answer. 421.86. What is the ratio of the Emissions (1000 metric ton of CO2 equivalent) in 2000 in Canada to that in Chile?
Provide a short and direct response. 5.13. What is the ratio of the Emissions (1000 metric ton of CO2 equivalent) in 2005 in Canada to that in Chile?
Give a very brief answer. 2.46. What is the ratio of the Emissions (1000 metric ton of CO2 equivalent) in 2008 in Canada to that in Chile?
Provide a short and direct response. 1.24. What is the difference between the highest and the second highest Emissions (1000 metric ton of CO2 equivalent) of 1990?
Make the answer very short. 7658.6. What is the difference between the highest and the second highest Emissions (1000 metric ton of CO2 equivalent) of 2000?
Your response must be concise. 2937.1. What is the difference between the highest and the second highest Emissions (1000 metric ton of CO2 equivalent) in 2005?
Your answer should be compact. 1447.8. What is the difference between the highest and the second highest Emissions (1000 metric ton of CO2 equivalent) in 2008?
Provide a short and direct response. 1922.4. What is the difference between the highest and the lowest Emissions (1000 metric ton of CO2 equivalent) in 1990?
Offer a very short reply. 1.17e+04. What is the difference between the highest and the lowest Emissions (1000 metric ton of CO2 equivalent) in 2000?
Offer a terse response. 6964.8. What is the difference between the highest and the lowest Emissions (1000 metric ton of CO2 equivalent) of 2005?
Make the answer very short. 3057.5. What is the difference between the highest and the lowest Emissions (1000 metric ton of CO2 equivalent) in 2008?
Your answer should be very brief. 3160.6. 